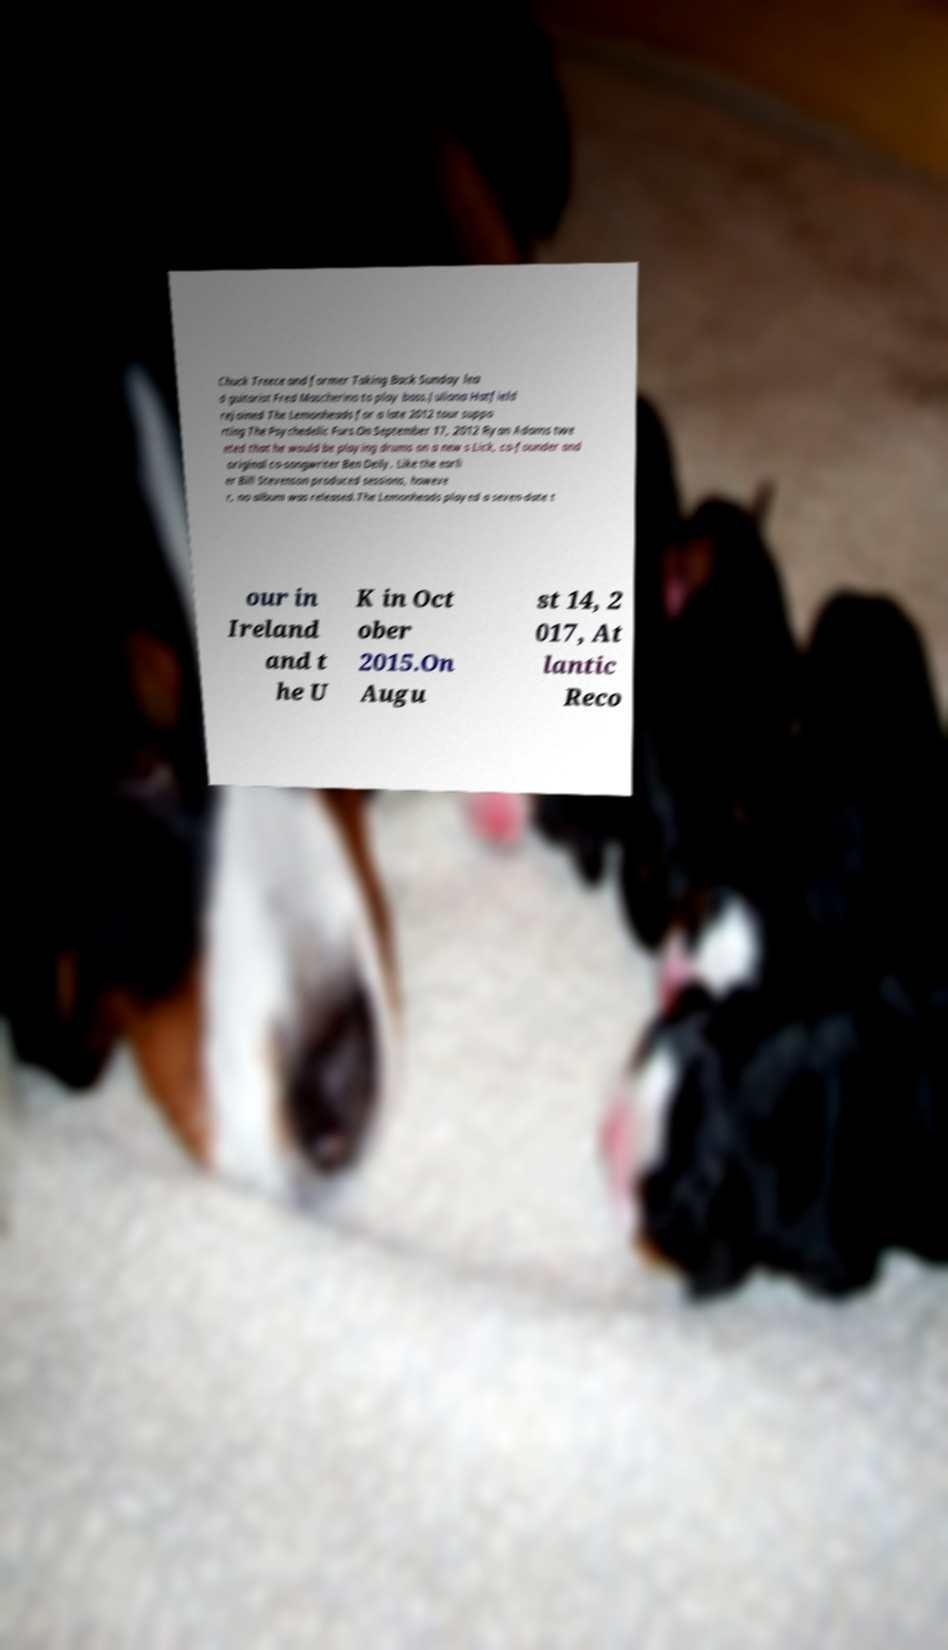Please read and relay the text visible in this image. What does it say? Chuck Treece and former Taking Back Sunday lea d guitarist Fred Mascherino to play bass.Juliana Hatfield rejoined The Lemonheads for a late 2012 tour suppo rting The Psychedelic Furs.On September 17, 2012 Ryan Adams twe eted that he would be playing drums on a new s Lick, co-founder and original co-songwriter Ben Deily. Like the earli er Bill Stevenson produced sessions, howeve r, no album was released.The Lemonheads played a seven-date t our in Ireland and t he U K in Oct ober 2015.On Augu st 14, 2 017, At lantic Reco 